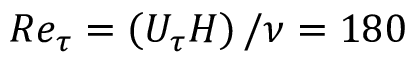Convert formula to latex. <formula><loc_0><loc_0><loc_500><loc_500>R e _ { \tau } = \left ( U _ { \tau } H \right ) / \nu = 1 8 0</formula> 